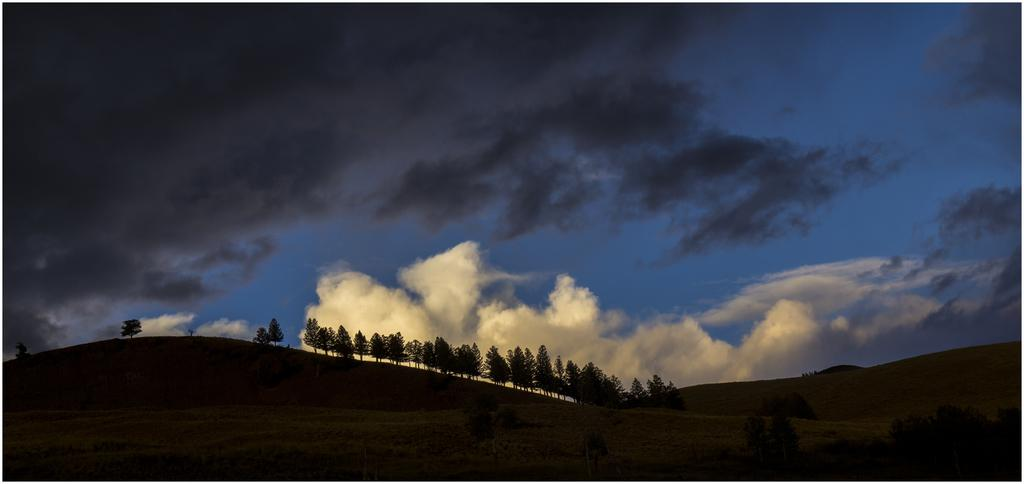What type of landscape is depicted in the image? There is a valley in the image. What type of vegetation can be seen in the image? There are trees and grass in the image. What is visible in the background of the image? The sky is visible in the background of the image, and there are clouds present. Where is the kitten playing with the wall in the image? There is no kitten or wall present in the image; it features a valley with trees, grass, and a sky with clouds. What type of oil can be seen dripping from the trees in the image? There is no oil present in the image; it only features a valley with trees, grass, and a sky with clouds. 